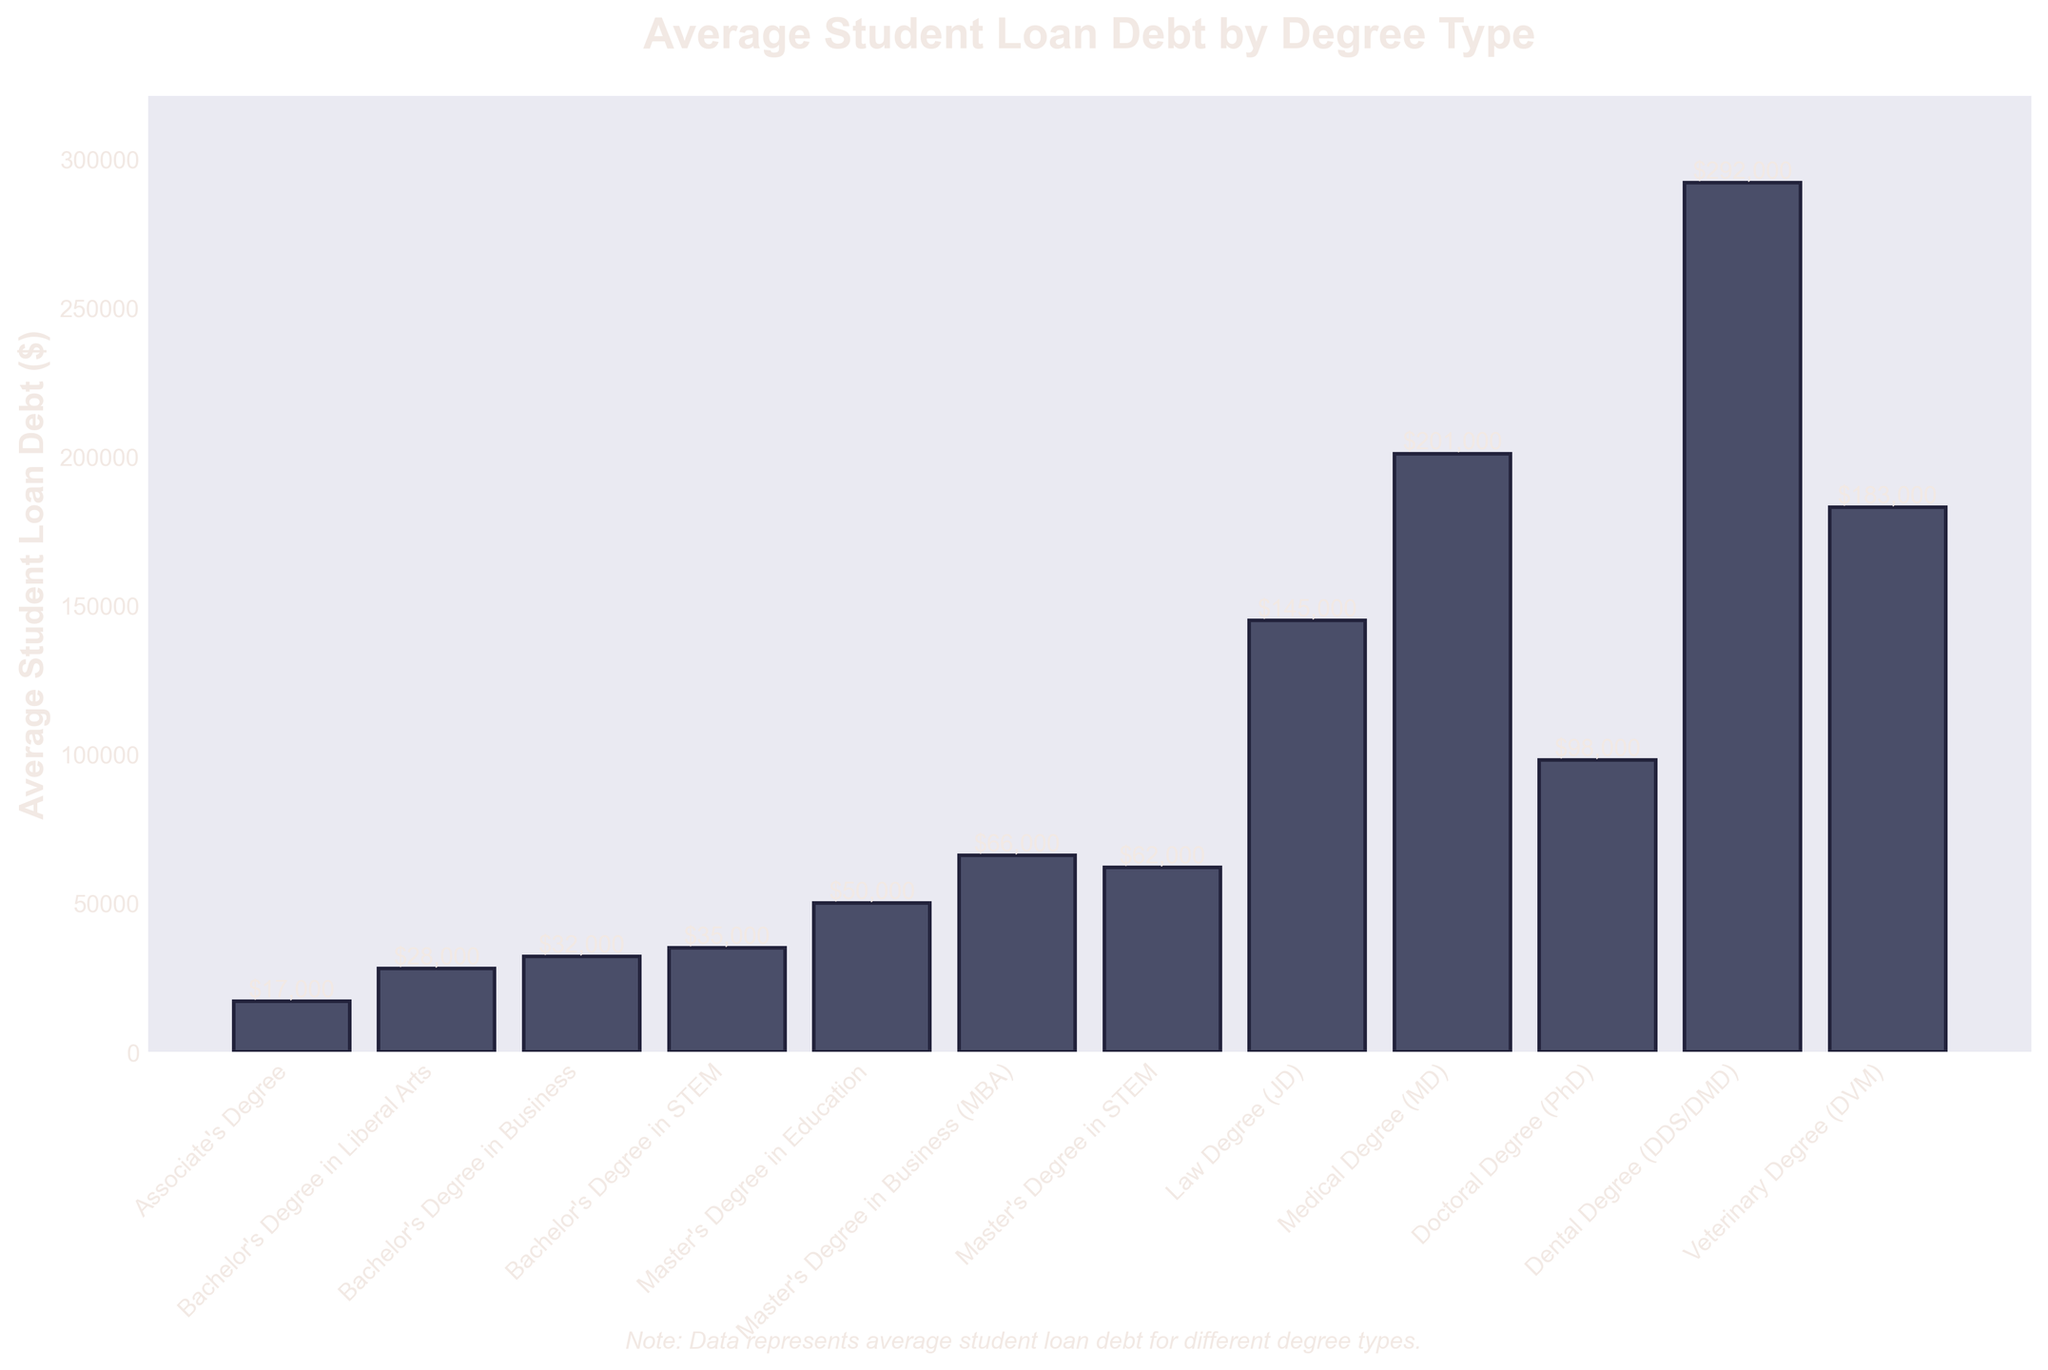What's the degree type with the highest average student loan debt? The bar chart shows the "Dental Degree (DDS/DMD)" as having the highest bar, which indicates the highest average student loan debt.
Answer: Dental Degree (DDS/DMD) How much higher is the average student loan debt for a Law Degree (JD) compared to a Master's Degree in Education? To find the difference, subtract the average student loan debt for a Master's Degree in Education ($50,000) from that of a Law Degree (JD) ($145,000): $145,000 - $50,000 = $95,000.
Answer: $95,000 Which degree type has a higher average student loan debt: Bachelor's Degree in Business or Bachelor's Degree in STEM? Comparing the heights of the bars for the Bachelor's Degree in Business ($32,000) and the Bachelor's Degree in STEM ($35,000), the STEM degree has the higher average debt.
Answer: Bachelor's Degree in STEM What is the total average student loan debt for all Master's Degree types combined? Add up the average student loan debts for Master's Degree in Education ($50,000), Master's Degree in Business (MBA) ($66,000), and Master's Degree in STEM ($62,000): $50,000 + $66,000 + $62,000 = $178,000.
Answer: $178,000 Which degree types have an average student loan debt above $100,000? By visually inspecting the bars, the degree types with debt above $100,000 are Law Degree (JD), Medical Degree (MD), Dental Degree (DDS/DMD), and Veterinary Degree (DVM).
Answer: Law Degree (JD), Medical Degree (MD), Dental Degree (DDS/DMD), Veterinary Degree (DVM) How much more is the average student loan debt for a Doctoral Degree (PhD) compared to an Associate's Degree? The average debt for a Doctoral Degree (PhD) is $98,000 and for an Associate's Degree is $17,000. Subtract these two: $98,000 - $17,000 = $81,000.
Answer: $81,000 What is the average student loan debt for the Bachelor's degree with the lowest debt? The Bachelor's Degree in Liberal Arts bar shows the lowest debt among Bachelor's degrees at $28,000.
Answer: $28,000 Is the average student loan debt for a Veterinary Degree (DVM) closer to that of a Medical Degree (MD) or a Dental Degree (DDS/DMD)? Compare the average student loan debts: Veterinary Degree (DVM) is $183,000, Medical Degree (MD) is $201,000, and Dental Degree (DDS/DMD) is $292,000. The difference between Veterinary Degree and Medical Degree is $201,000 - $183,000 = $18,000, whereas the difference with Dental Degree is $292,000 - $183,000 = $109,000. The Veterinary Degree debt is closer to the Medical Degree.
Answer: Medical Degree (MD) What is the average student loan debt for a Bachelor's Degree in Business compared to a Bachelor's Degree in Liberal Arts? The Bachelor's Degree in Business has an average student loan debt of $32,000, while Bachelor's Degree in Liberal Arts has $28,000.
Answer: Bachelor's Degree in Business: $32,000, Bachelor's Degree in Liberal Arts: $28,000 How much lower is the average student loan debt for an Associate's Degree compared to the highest average student loan debt? The highest average student loan debt is $292,000 for a Dental Degree (DDS/DMD), and the Associate's Degree has an average debt of $17,000. Subtract these two: $292,000 - $17,000 = $275,000.
Answer: $275,000 